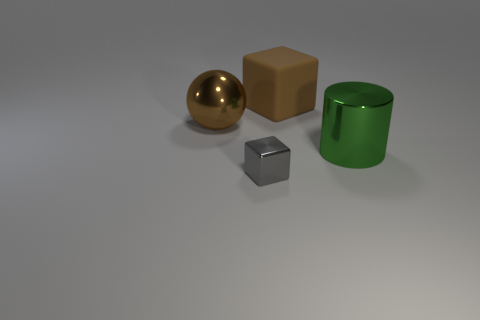How many other objects are the same color as the big matte object?
Keep it short and to the point. 1. There is a brown object that is the same shape as the gray metal object; what size is it?
Your answer should be very brief. Large. Does the brown thing that is in front of the large brown matte object have the same material as the brown object that is right of the small metallic block?
Your answer should be very brief. No. Are there fewer big brown matte cubes that are in front of the big green metal thing than big blue metal balls?
Provide a succinct answer. No. Is there anything else that is the same shape as the brown metal object?
Make the answer very short. No. There is a big rubber object that is the same shape as the tiny gray metal object; what color is it?
Your response must be concise. Brown. There is a brown object on the left side of the brown block; does it have the same size as the big green object?
Your response must be concise. Yes. What is the size of the block in front of the large shiny thing behind the large green thing?
Make the answer very short. Small. Is the material of the big brown cube the same as the big brown thing to the left of the matte object?
Your answer should be compact. No. Is the number of small gray metallic objects on the left side of the gray metallic block less than the number of big green metallic objects in front of the large brown matte block?
Your answer should be very brief. Yes. 